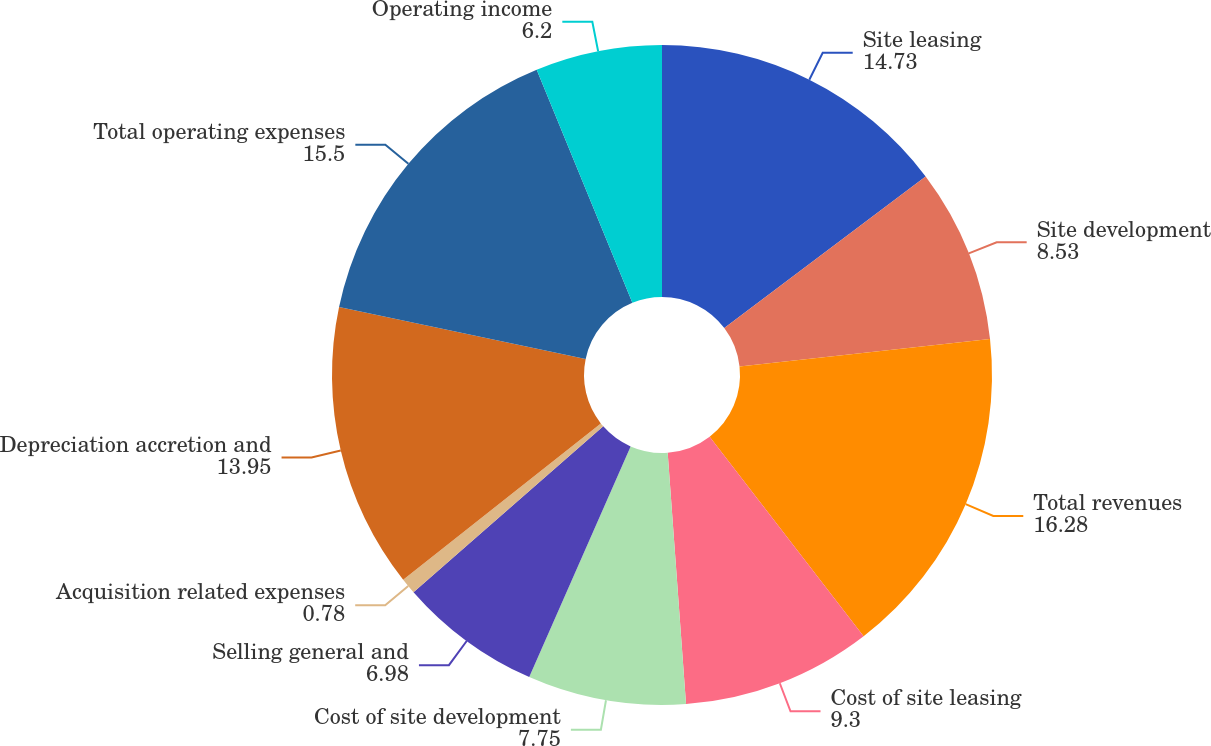Convert chart. <chart><loc_0><loc_0><loc_500><loc_500><pie_chart><fcel>Site leasing<fcel>Site development<fcel>Total revenues<fcel>Cost of site leasing<fcel>Cost of site development<fcel>Selling general and<fcel>Acquisition related expenses<fcel>Depreciation accretion and<fcel>Total operating expenses<fcel>Operating income<nl><fcel>14.73%<fcel>8.53%<fcel>16.28%<fcel>9.3%<fcel>7.75%<fcel>6.98%<fcel>0.78%<fcel>13.95%<fcel>15.5%<fcel>6.2%<nl></chart> 